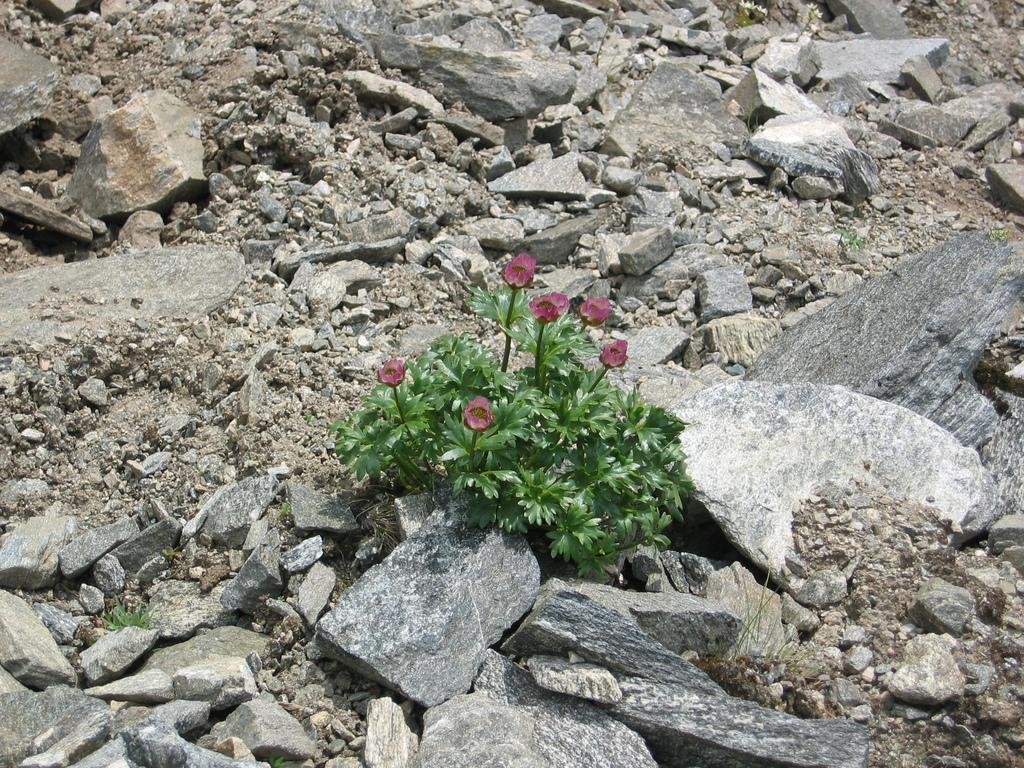What is located in the middle of the image? There are plants and flowers in the middle of the image. What type of plants are present in the image? The plants in the image are accompanied by flowers. What can be seen in the background of the image? There are stones and land visible in the background of the image. How many cherries can be seen hanging from the trees in the image? There are no trees or cherries present in the image; it features plants and flowers with stones and land in the background. 